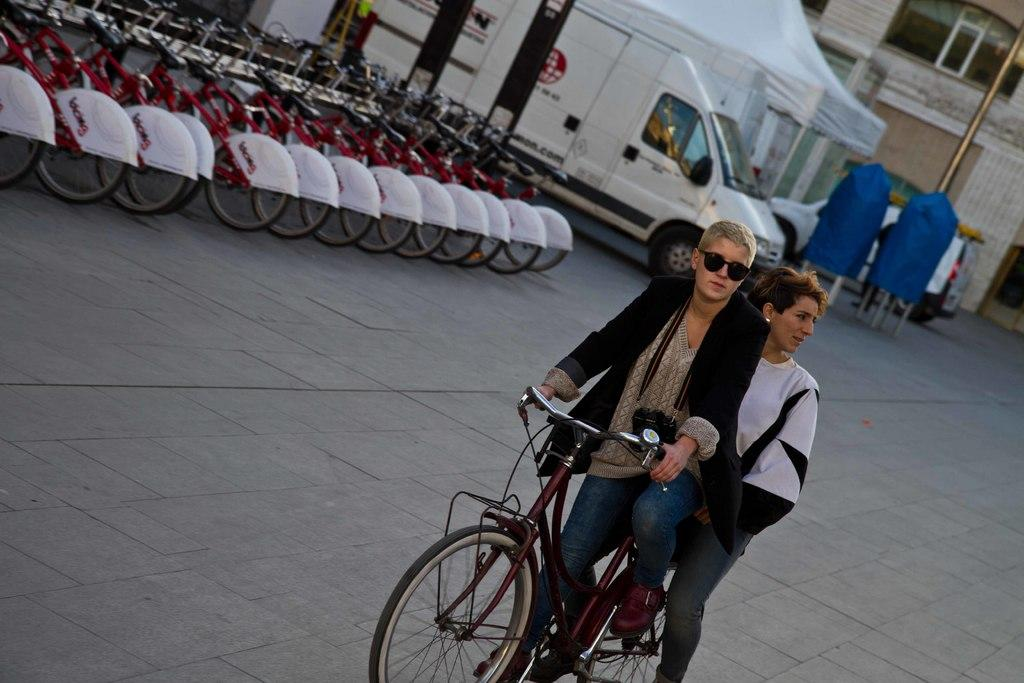What are the two persons in the image doing? The two persons are sitting on a bicycle in the middle of the image. What can be seen on the left side of the image? There are many bicycles on the left side of the image. What is visible in the background of the image? There is a vehicle, a tent, a pole, and a building in the background of the image. What type of cherries are being used to decorate the tent in the image? There are no cherries present in the image, and the tent is not being decorated with any fruits. 